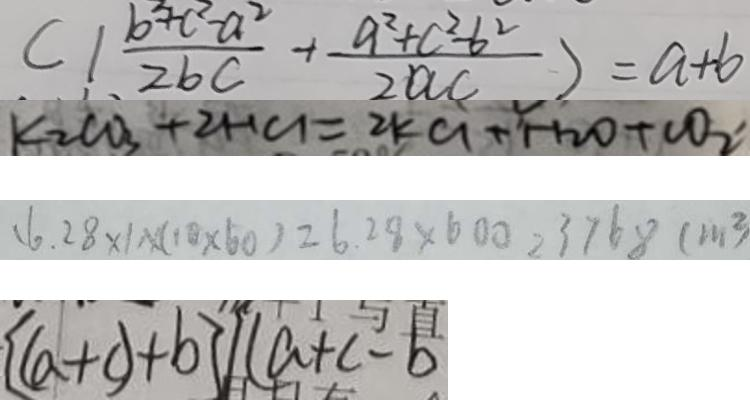<formula> <loc_0><loc_0><loc_500><loc_500>( 1 \frac { b ^ { 2 } + c ^ { 2 } - a ^ { 2 } } { 2 b c } + \frac { a ^ { 2 } + c ^ { 2 } - b ^ { 2 } } { 2 a c } ) = a + b 
 k _ { 2 } C O _ { 3 } + 2 H C L = 2 K C L + H _ { 2 } O + C O _ { 2 } ^ { \prime } 
 ( 6 . 2 8 \times 1 ) \times ( 1 0 \times 6 0 ) = 6 . 2 8 \times 6 0 0 = 3 7 6 8 ( m ^ { 2 } ) 
 [ ( a + c ) + b ] \vert ( a + c - b</formula> 